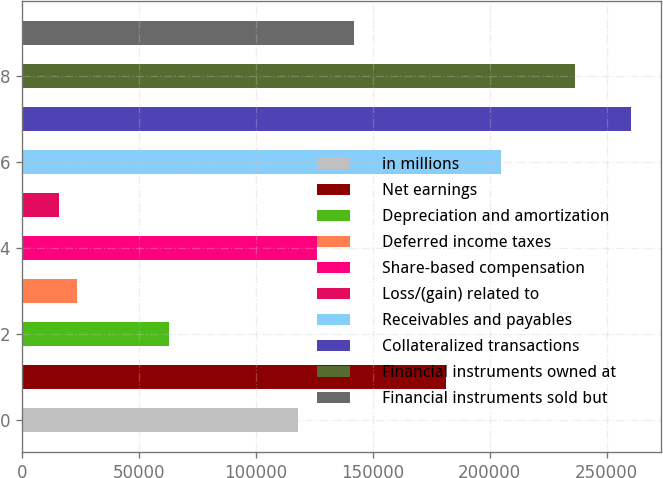Convert chart to OTSL. <chart><loc_0><loc_0><loc_500><loc_500><bar_chart><fcel>in millions<fcel>Net earnings<fcel>Depreciation and amortization<fcel>Deferred income taxes<fcel>Share-based compensation<fcel>Loss/(gain) related to<fcel>Receivables and payables<fcel>Collateralized transactions<fcel>Financial instruments owned at<fcel>Financial instruments sold but<nl><fcel>118286<fcel>181355<fcel>63099.6<fcel>23681.1<fcel>126169<fcel>15797.4<fcel>205006<fcel>260192<fcel>236541<fcel>141937<nl></chart> 